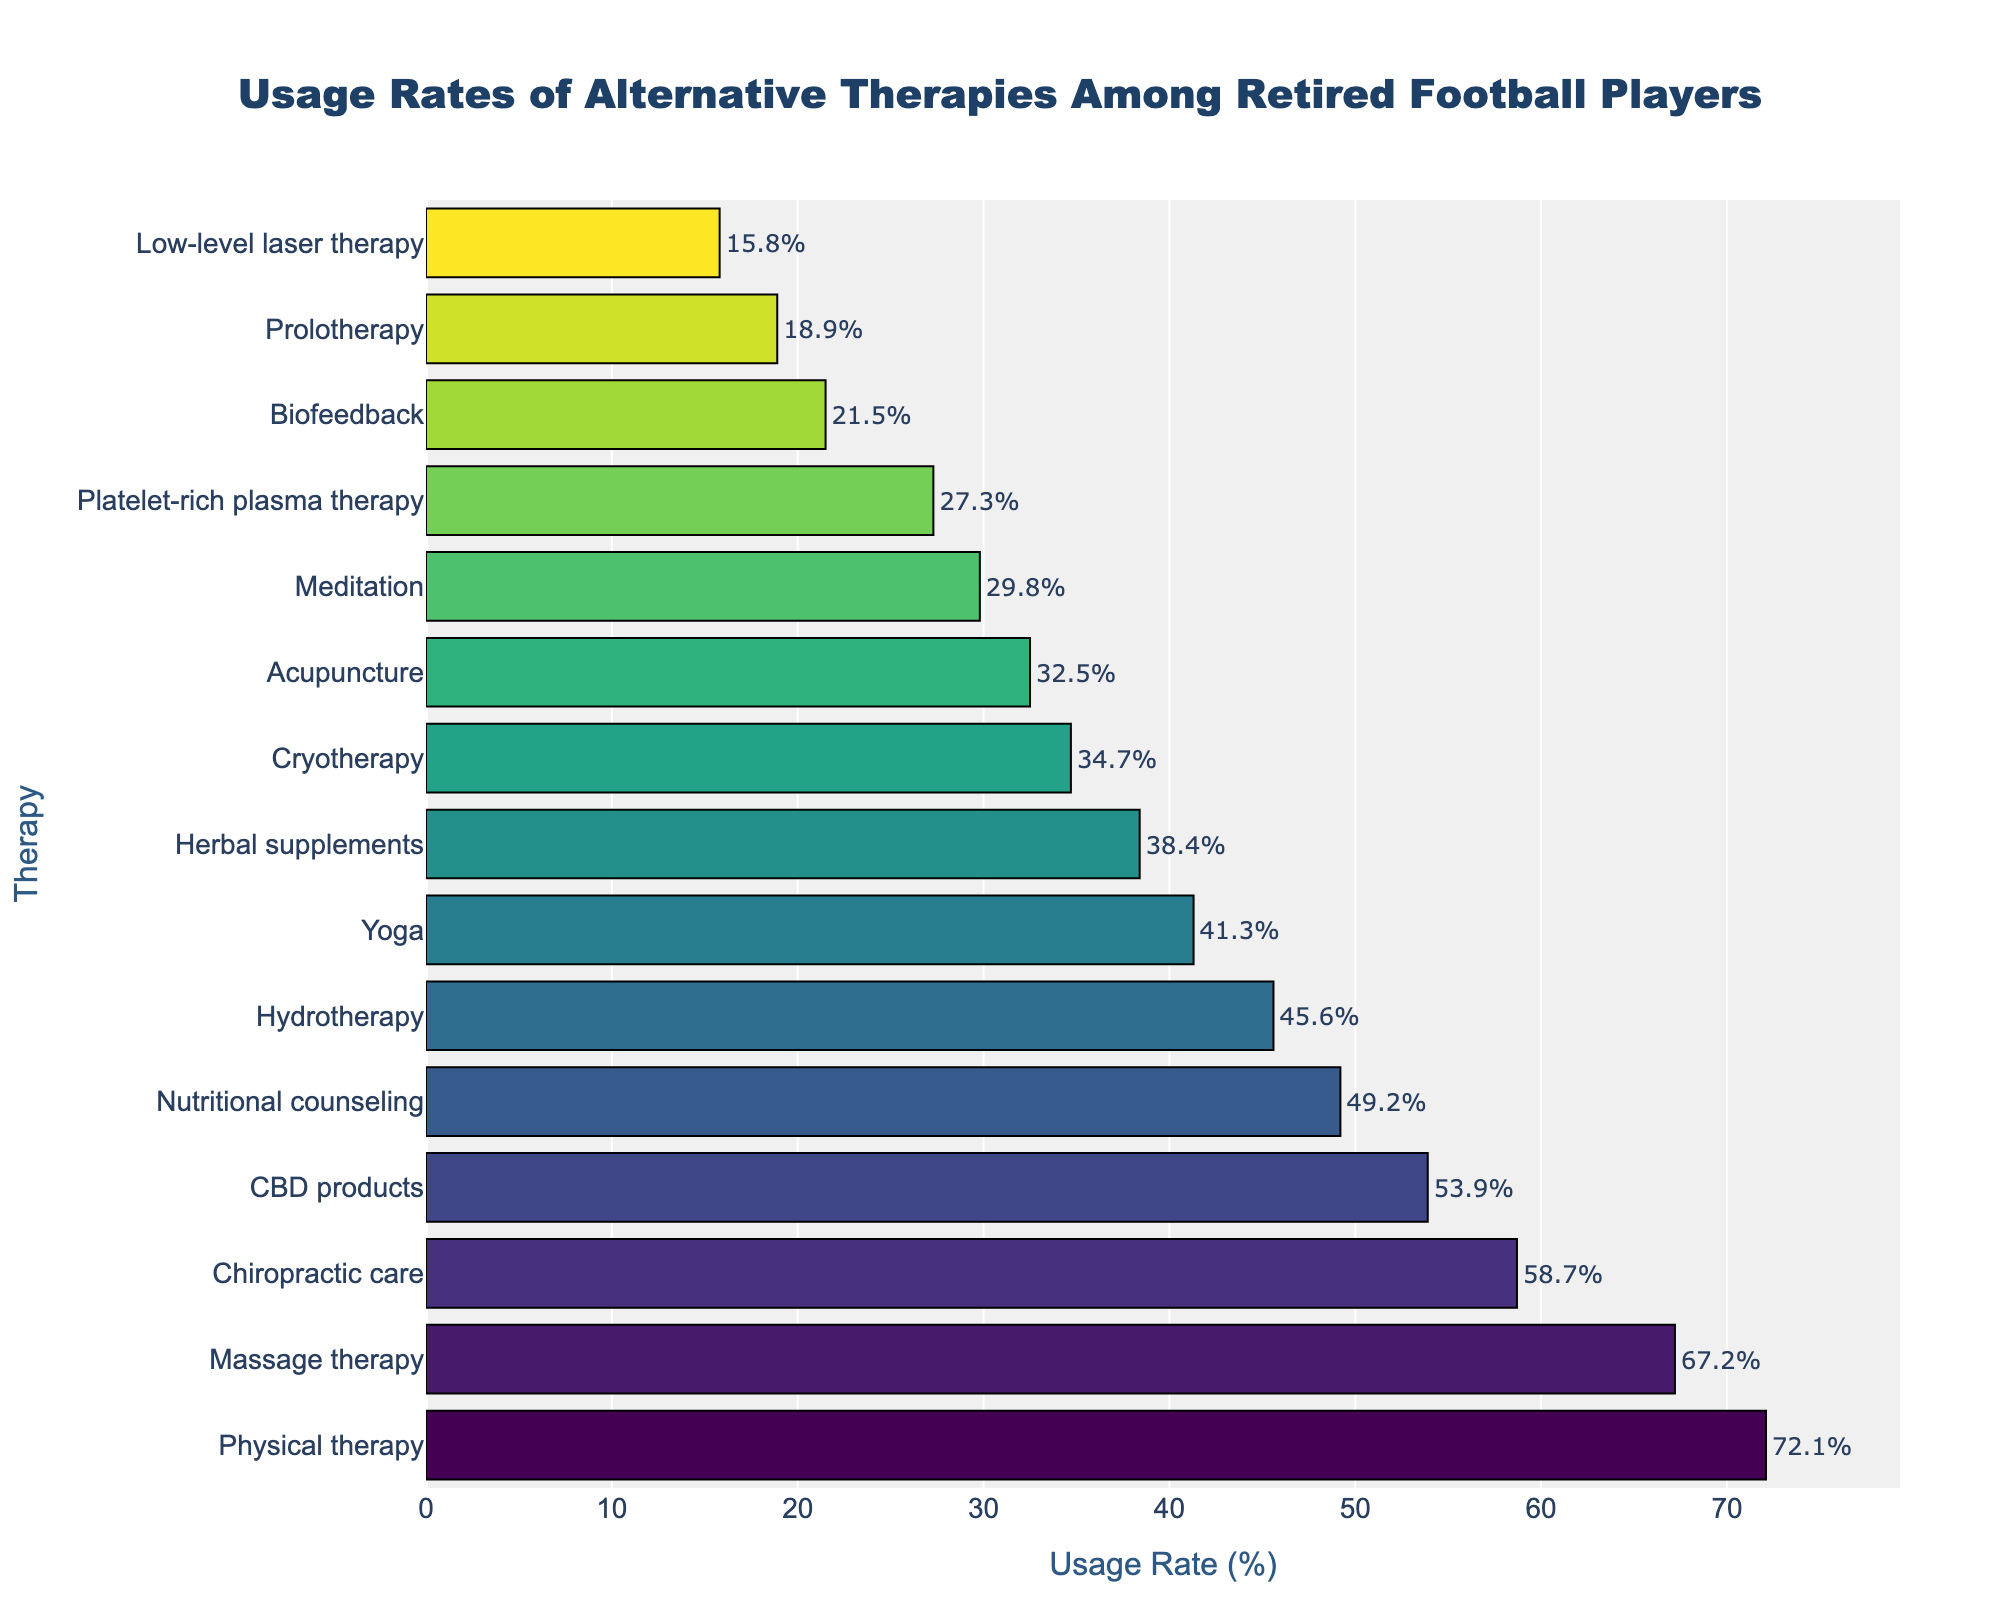Which therapy has the highest usage rate among retired football players? By looking at the bar chart, we can see which bar is the longest, indicating the highest usage rate. The longest bar belongs to Physical therapy.
Answer: Physical therapy What is the difference in usage rates between Massage therapy and Acupuncture? Find the usage rates of Massage therapy (67.2%) and Acupuncture (32.5%) from the bar chart. Subtract the smaller rate from the larger: 67.2% - 32.5% = 34.7%.
Answer: 34.7% Which therapy has a higher usage rate: Hydrotherapy or CBD products? Compare the lengths of the bars for Hydrotherapy (45.6%) and CBD products (53.9%) from the chart. The longer bar indicates a higher usage rate.
Answer: CBD products How many therapies have a usage rate greater than 50%? Count the bars in the chart with usage rates above 50%. These are Chiropractic care (58.7%), Massage therapy (67.2%), Physical therapy (72.1%), and CBD products (53.9%). There are four such therapies.
Answer: 4 Among Yoga, Meditation, and Nutritional counseling, which has the lowest usage rate? Compare the usage rates of Yoga (41.3%), Meditation (29.8%), and Nutritional counseling (49.2%) from the chart. The lowest usage rate is for Meditation.
Answer: Meditation What is the average usage rate of Biofeedback, Prolotherapy, and Low-level laser therapy? Find the usage rates of Biofeedback (21.5%), Prolotherapy (18.9%), and Low-level laser therapy (15.8%) from the chart. Add them together and divide by 3 for the average: (21.5% + 18.9% + 15.8%) / 3 = 18.73%.
Answer: 18.73% Is the usage rate of Cryotherapy closer to that of Acupuncture or Platelet-rich plasma therapy? Compare the usage rates of Cryotherapy (34.7%), Acupuncture (32.5%), and Platelet-rich plasma therapy (27.3%). The difference between Cryotherapy and Acupuncture is 34.7% - 32.5% = 2.2%, and for Platelet-rich plasma therapy it’s 34.7% - 27.3% = 7.4%. Cryotherapy is closer to Acupuncture.
Answer: Acupuncture What is the combined usage rate of Chiropractic care and Yoga? Find the usage rates of Chiropractic care (58.7%) and Yoga (41.3%) from the chart. Add them together for the combined rate: 58.7% + 41.3% = 100%.
Answer: 100% Which therapies have a usage rate under 30%? Identify the bars with usage rates below 30% from the chart. These are Meditation (29.8%), Platelet-rich plasma therapy (27.3%), Prolotherapy (18.9%), Low-level laser therapy (15.8%), and Biofeedback (21.5%).
Answer: Meditation, Platelet-rich plasma therapy, Prolotherapy, Low-level laser therapy, Biofeedback 